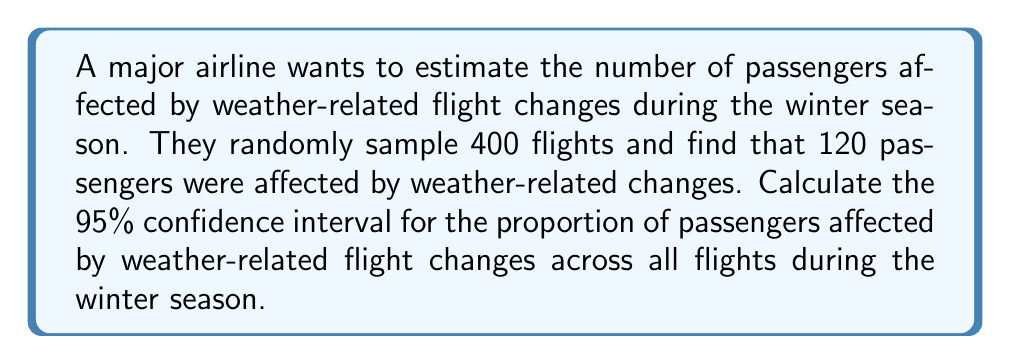Provide a solution to this math problem. To compute the confidence interval, we'll follow these steps:

1) First, calculate the sample proportion:
   $\hat{p} = \frac{120}{400} = 0.3$

2) The formula for the confidence interval is:
   $$\hat{p} \pm z_{\alpha/2} \sqrt{\frac{\hat{p}(1-\hat{p})}{n}}$$
   where $z_{\alpha/2}$ is the critical value for the desired confidence level.

3) For a 95% confidence interval, $z_{\alpha/2} = 1.96$

4) Calculate the standard error:
   $$SE = \sqrt{\frac{\hat{p}(1-\hat{p})}{n}} = \sqrt{\frac{0.3(1-0.3)}{400}} = 0.0229$$

5) Now, we can compute the margin of error:
   $$ME = 1.96 \times 0.0229 = 0.0449$$

6) Finally, calculate the confidence interval:
   Lower bound: $0.3 - 0.0449 = 0.2551$
   Upper bound: $0.3 + 0.0449 = 0.3449$

Therefore, we are 95% confident that the true proportion of passengers affected by weather-related flight changes is between 0.2551 and 0.3449, or between 25.51% and 34.49%.
Answer: (0.2551, 0.3449) 